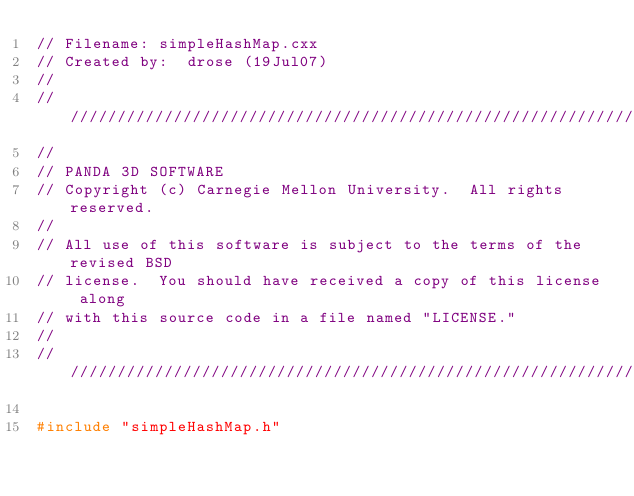<code> <loc_0><loc_0><loc_500><loc_500><_C++_>// Filename: simpleHashMap.cxx
// Created by:  drose (19Jul07)
//
////////////////////////////////////////////////////////////////////
//
// PANDA 3D SOFTWARE
// Copyright (c) Carnegie Mellon University.  All rights reserved.
//
// All use of this software is subject to the terms of the revised BSD
// license.  You should have received a copy of this license along
// with this source code in a file named "LICENSE."
//
////////////////////////////////////////////////////////////////////

#include "simpleHashMap.h"
</code> 